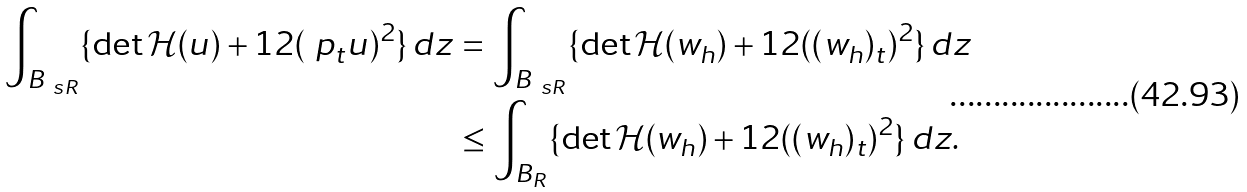Convert formula to latex. <formula><loc_0><loc_0><loc_500><loc_500>\int _ { B _ { \ s R } } \{ \det \mathcal { H } ( u ) + 1 2 ( \ p _ { t } u ) ^ { 2 } \} \, d z & = \int _ { B _ { \ s R } } \{ \det \mathcal { H } ( w _ { h } ) + 1 2 ( ( w _ { h } ) _ { t } ) ^ { 2 } \} \, d z \\ & \leq \int _ { B _ { R } } \{ \det \mathcal { H } ( w _ { h } ) + 1 2 ( ( w _ { h } ) _ { t } ) ^ { 2 } \} \, d z .</formula> 